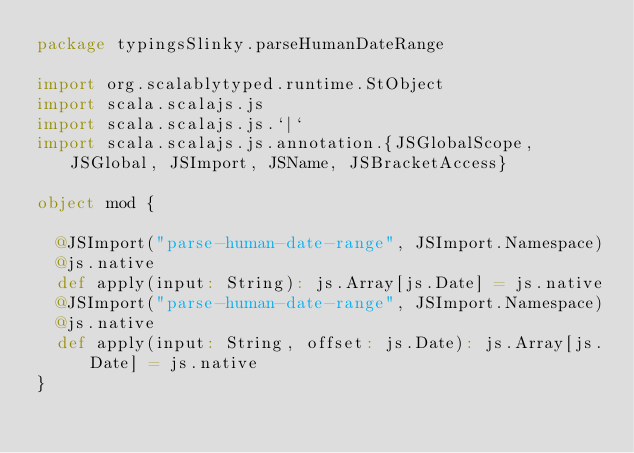<code> <loc_0><loc_0><loc_500><loc_500><_Scala_>package typingsSlinky.parseHumanDateRange

import org.scalablytyped.runtime.StObject
import scala.scalajs.js
import scala.scalajs.js.`|`
import scala.scalajs.js.annotation.{JSGlobalScope, JSGlobal, JSImport, JSName, JSBracketAccess}

object mod {
  
  @JSImport("parse-human-date-range", JSImport.Namespace)
  @js.native
  def apply(input: String): js.Array[js.Date] = js.native
  @JSImport("parse-human-date-range", JSImport.Namespace)
  @js.native
  def apply(input: String, offset: js.Date): js.Array[js.Date] = js.native
}
</code> 